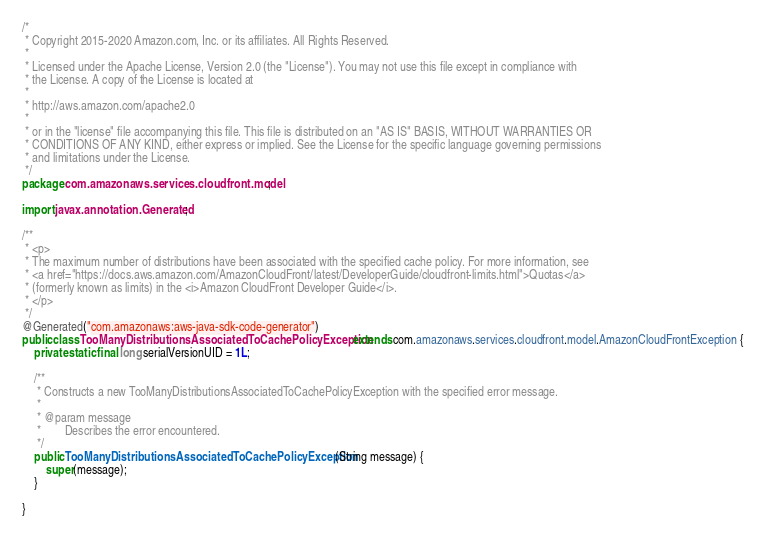Convert code to text. <code><loc_0><loc_0><loc_500><loc_500><_Java_>/*
 * Copyright 2015-2020 Amazon.com, Inc. or its affiliates. All Rights Reserved.
 * 
 * Licensed under the Apache License, Version 2.0 (the "License"). You may not use this file except in compliance with
 * the License. A copy of the License is located at
 * 
 * http://aws.amazon.com/apache2.0
 * 
 * or in the "license" file accompanying this file. This file is distributed on an "AS IS" BASIS, WITHOUT WARRANTIES OR
 * CONDITIONS OF ANY KIND, either express or implied. See the License for the specific language governing permissions
 * and limitations under the License.
 */
package com.amazonaws.services.cloudfront.model;

import javax.annotation.Generated;

/**
 * <p>
 * The maximum number of distributions have been associated with the specified cache policy. For more information, see
 * <a href="https://docs.aws.amazon.com/AmazonCloudFront/latest/DeveloperGuide/cloudfront-limits.html">Quotas</a>
 * (formerly known as limits) in the <i>Amazon CloudFront Developer Guide</i>.
 * </p>
 */
@Generated("com.amazonaws:aws-java-sdk-code-generator")
public class TooManyDistributionsAssociatedToCachePolicyException extends com.amazonaws.services.cloudfront.model.AmazonCloudFrontException {
    private static final long serialVersionUID = 1L;

    /**
     * Constructs a new TooManyDistributionsAssociatedToCachePolicyException with the specified error message.
     *
     * @param message
     *        Describes the error encountered.
     */
    public TooManyDistributionsAssociatedToCachePolicyException(String message) {
        super(message);
    }

}
</code> 